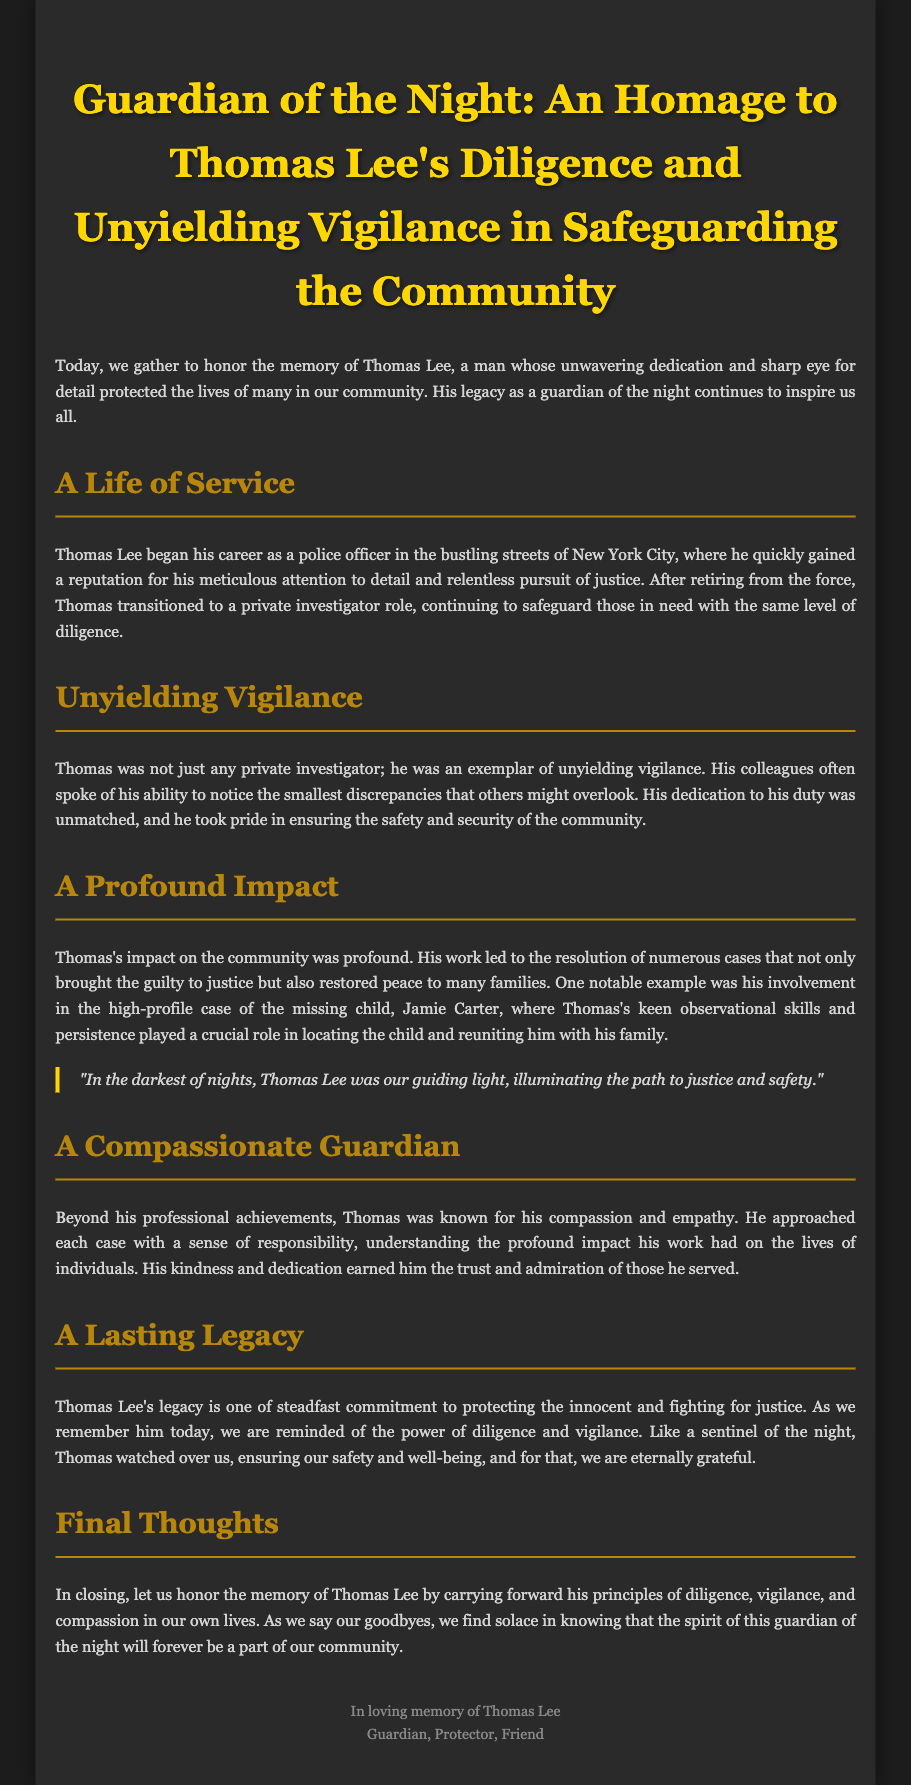What was Thomas Lee's role before becoming a private investigator? Thomas Lee began his career as a police officer in New York City.
Answer: Police officer What notable case did Thomas Lee contribute to? Thomas played a crucial role in the high-profile case of the missing child, Jamie Carter.
Answer: Jamie Carter What is one of Thomas Lee's key characteristics highlighted in the eulogy? The eulogy refers to his meticulous attention to detail.
Answer: Attention to detail Which quality of Thomas Lee earned him the trust of those he served? He approached each case with a sense of responsibility and compassion.
Answer: Compassion What does Thomas Lee represent in the context of the eulogy? He is described as a guiding light, illuminating the path to justice and safety.
Answer: Guiding light How does the eulogy describe Thomas Lee's impact on the community? His work led to the resolution of numerous cases that restored peace to families.
Answer: Restored peace What kind of legacy did Thomas Lee leave behind? Thomas Lee's legacy is one of steadfast commitment to protecting the innocent and fighting for justice.
Answer: Steadfast commitment What phrase is used to describe Thomas Lee’s vigilance? He is described as an exemplar of unyielding vigilance.
Answer: Unyielding vigilance What message does the eulogy convey for honoring Thomas Lee's memory? We should carry forward his principles of diligence, vigilance, and compassion.
Answer: Diligence, vigilance, and compassion 